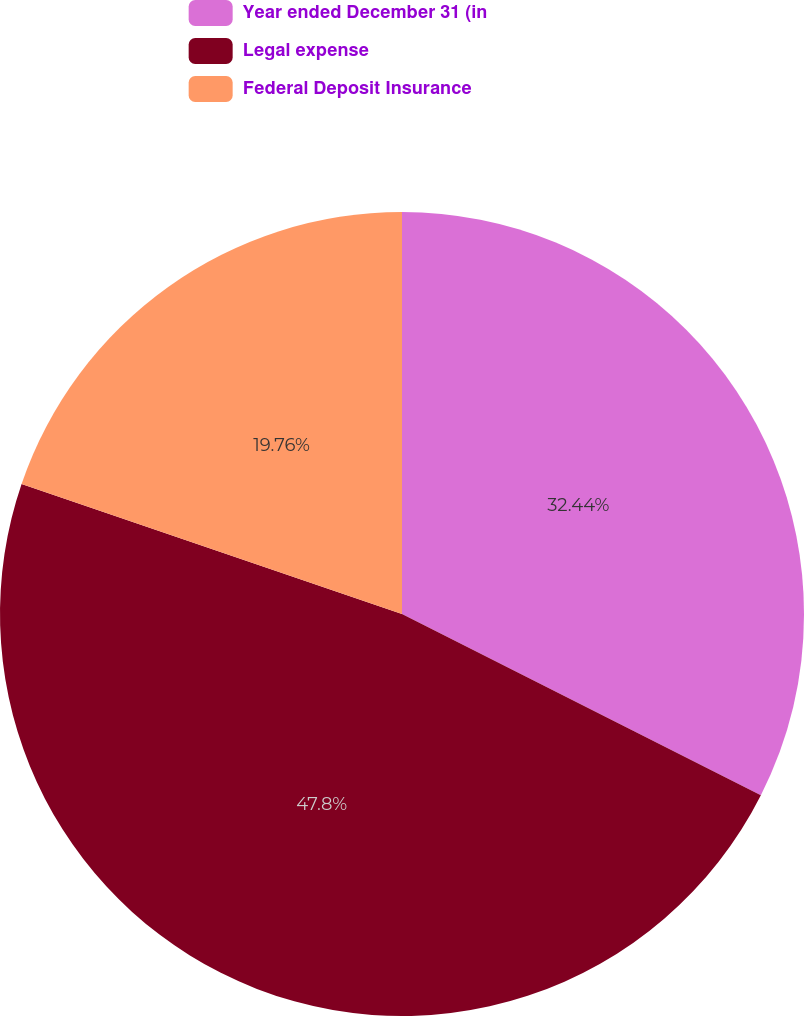Convert chart. <chart><loc_0><loc_0><loc_500><loc_500><pie_chart><fcel>Year ended December 31 (in<fcel>Legal expense<fcel>Federal Deposit Insurance<nl><fcel>32.44%<fcel>47.8%<fcel>19.76%<nl></chart> 